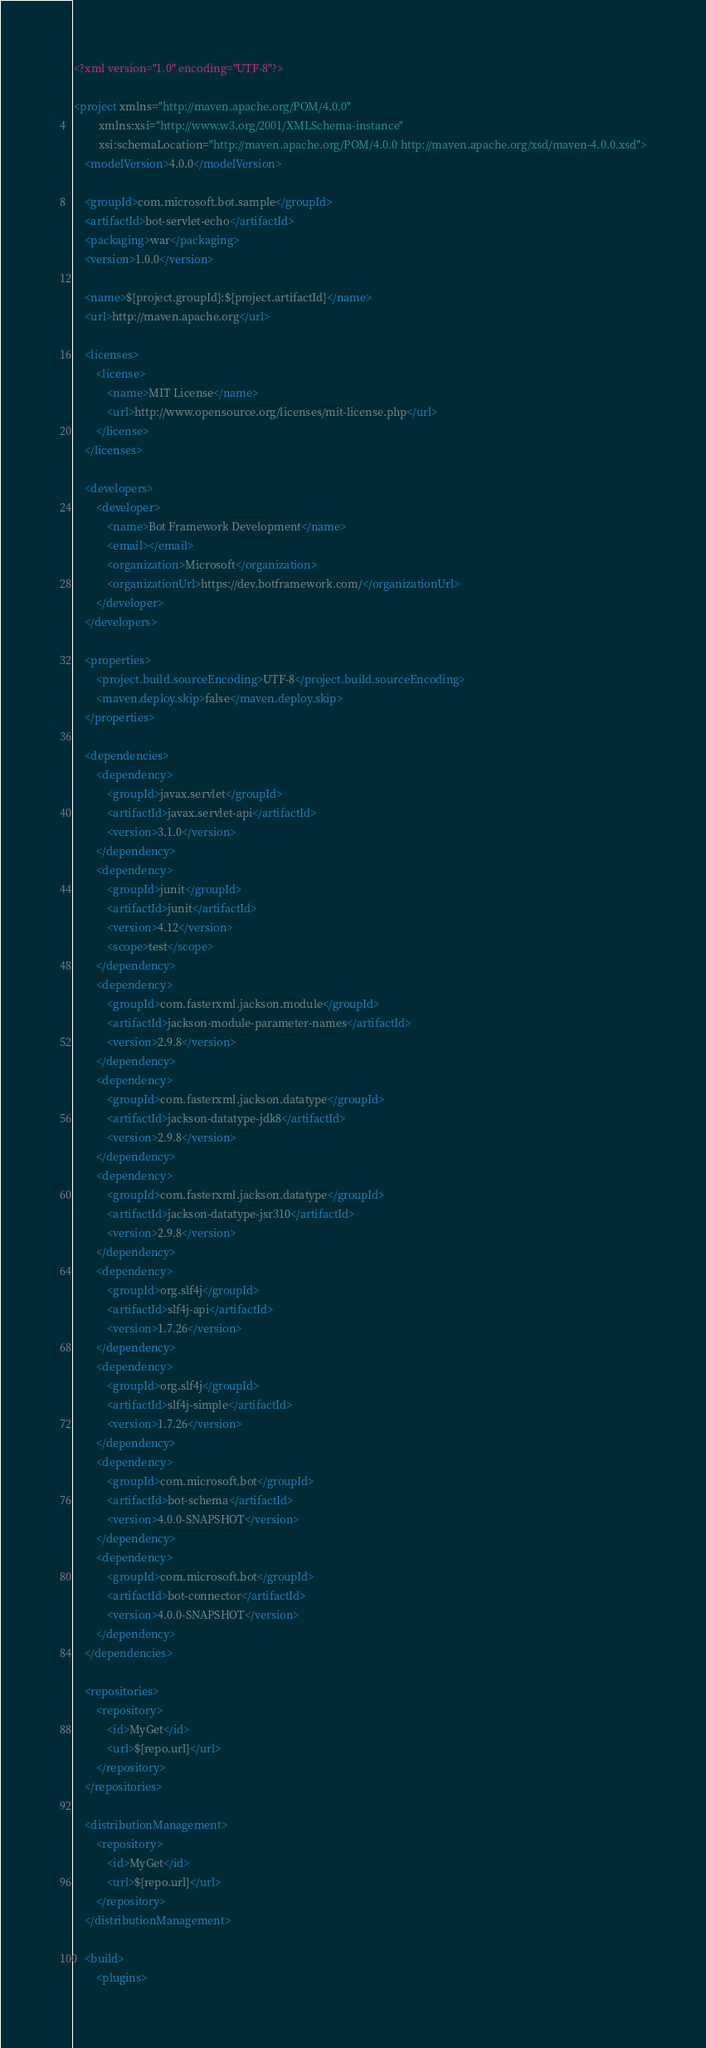Convert code to text. <code><loc_0><loc_0><loc_500><loc_500><_XML_><?xml version="1.0" encoding="UTF-8"?>

<project xmlns="http://maven.apache.org/POM/4.0.0"
         xmlns:xsi="http://www.w3.org/2001/XMLSchema-instance"
         xsi:schemaLocation="http://maven.apache.org/POM/4.0.0 http://maven.apache.org/xsd/maven-4.0.0.xsd">
    <modelVersion>4.0.0</modelVersion>

    <groupId>com.microsoft.bot.sample</groupId>
    <artifactId>bot-servlet-echo</artifactId>
    <packaging>war</packaging>
    <version>1.0.0</version>

    <name>${project.groupId}:${project.artifactId}</name>
    <url>http://maven.apache.org</url>

    <licenses>
        <license>
            <name>MIT License</name>
            <url>http://www.opensource.org/licenses/mit-license.php</url>
        </license>
    </licenses>

    <developers>
        <developer>
            <name>Bot Framework Development</name>
            <email></email>
            <organization>Microsoft</organization>
            <organizationUrl>https://dev.botframework.com/</organizationUrl>
        </developer>
    </developers>

    <properties>
        <project.build.sourceEncoding>UTF-8</project.build.sourceEncoding>
        <maven.deploy.skip>false</maven.deploy.skip>
    </properties>

    <dependencies>
        <dependency>
            <groupId>javax.servlet</groupId>
            <artifactId>javax.servlet-api</artifactId>
            <version>3.1.0</version>
        </dependency>
        <dependency>
            <groupId>junit</groupId>
            <artifactId>junit</artifactId>
            <version>4.12</version>
            <scope>test</scope>
        </dependency>
        <dependency>
            <groupId>com.fasterxml.jackson.module</groupId>
            <artifactId>jackson-module-parameter-names</artifactId>
            <version>2.9.8</version>
        </dependency>
        <dependency>
            <groupId>com.fasterxml.jackson.datatype</groupId>
            <artifactId>jackson-datatype-jdk8</artifactId>
            <version>2.9.8</version>
        </dependency>
        <dependency>
            <groupId>com.fasterxml.jackson.datatype</groupId>
            <artifactId>jackson-datatype-jsr310</artifactId>
            <version>2.9.8</version>
        </dependency>
        <dependency>
            <groupId>org.slf4j</groupId>
            <artifactId>slf4j-api</artifactId>
            <version>1.7.26</version>
        </dependency>
        <dependency>
            <groupId>org.slf4j</groupId>
            <artifactId>slf4j-simple</artifactId>
            <version>1.7.26</version>
        </dependency>
        <dependency>
            <groupId>com.microsoft.bot</groupId>
            <artifactId>bot-schema</artifactId>
            <version>4.0.0-SNAPSHOT</version>
        </dependency>
        <dependency>
            <groupId>com.microsoft.bot</groupId>
            <artifactId>bot-connector</artifactId>
            <version>4.0.0-SNAPSHOT</version>
        </dependency>
    </dependencies>

    <repositories>
        <repository>
            <id>MyGet</id>
            <url>${repo.url}</url>
        </repository>
    </repositories>

    <distributionManagement>
        <repository>
            <id>MyGet</id>
            <url>${repo.url}</url>
        </repository>
    </distributionManagement>

    <build>
        <plugins></code> 